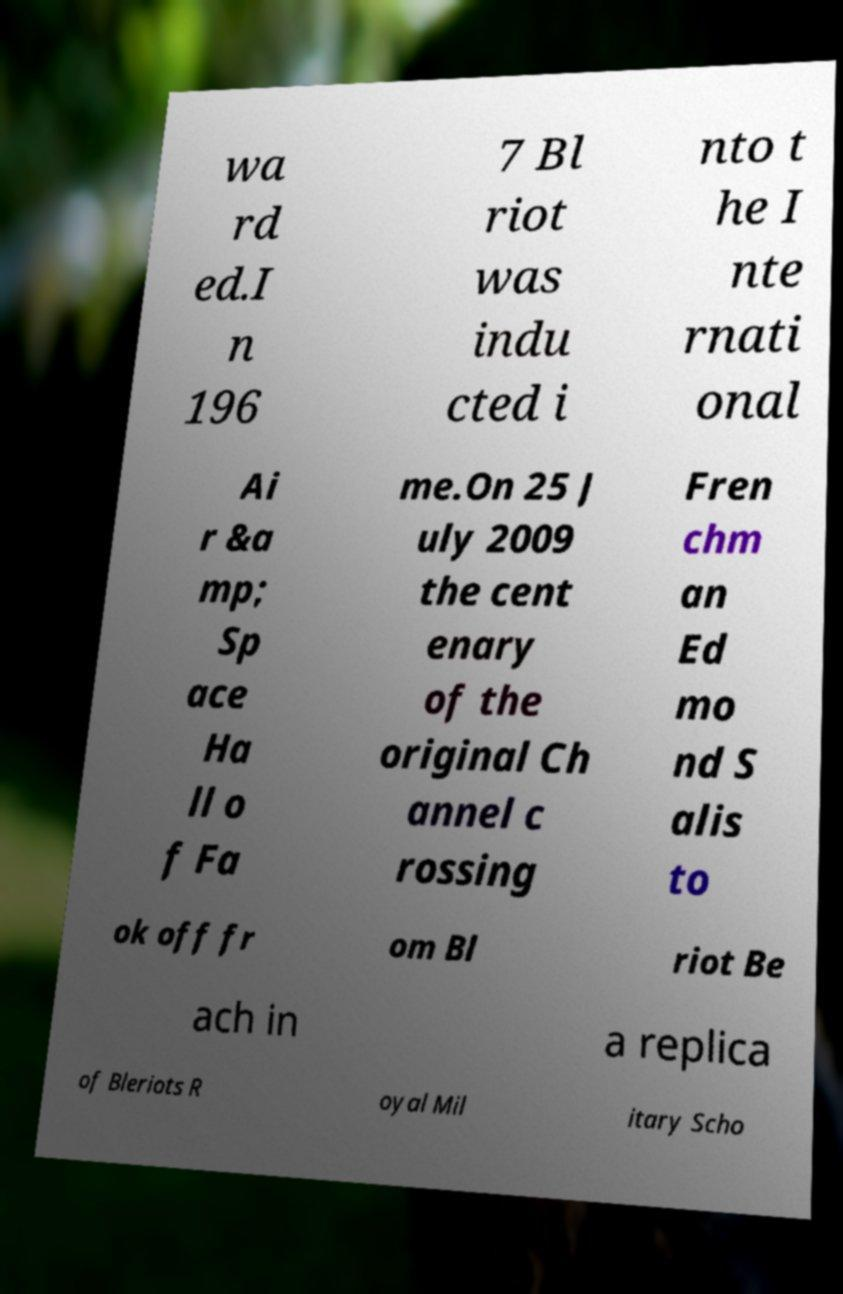For documentation purposes, I need the text within this image transcribed. Could you provide that? wa rd ed.I n 196 7 Bl riot was indu cted i nto t he I nte rnati onal Ai r &a mp; Sp ace Ha ll o f Fa me.On 25 J uly 2009 the cent enary of the original Ch annel c rossing Fren chm an Ed mo nd S alis to ok off fr om Bl riot Be ach in a replica of Bleriots R oyal Mil itary Scho 